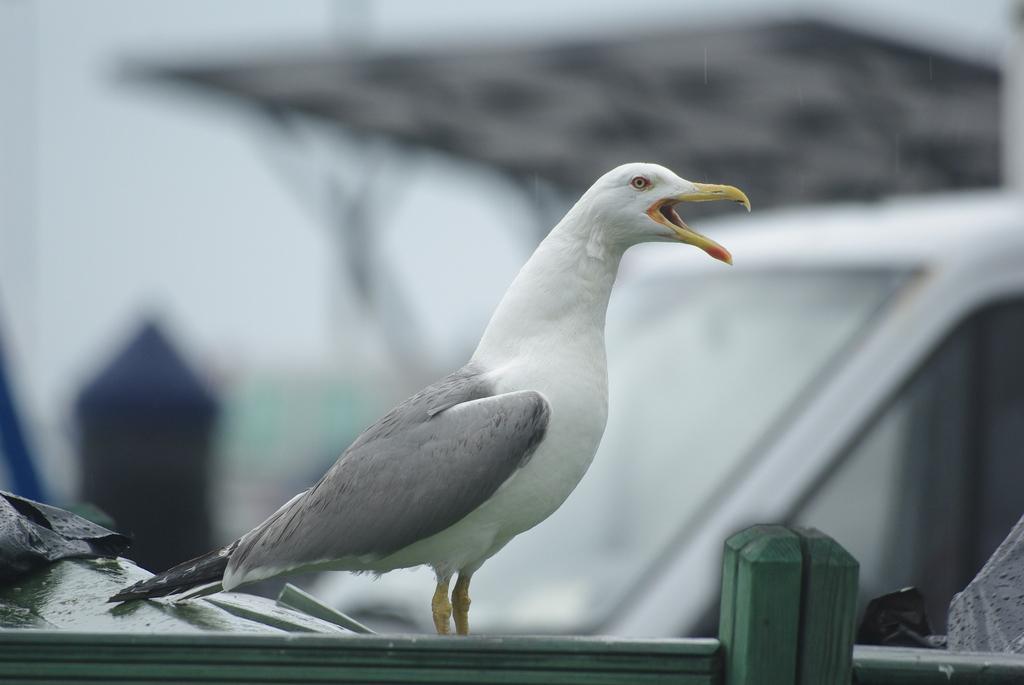Describe this image in one or two sentences. In the foreground of the picture we can see bird, railing and other objects. The background is blurred. 